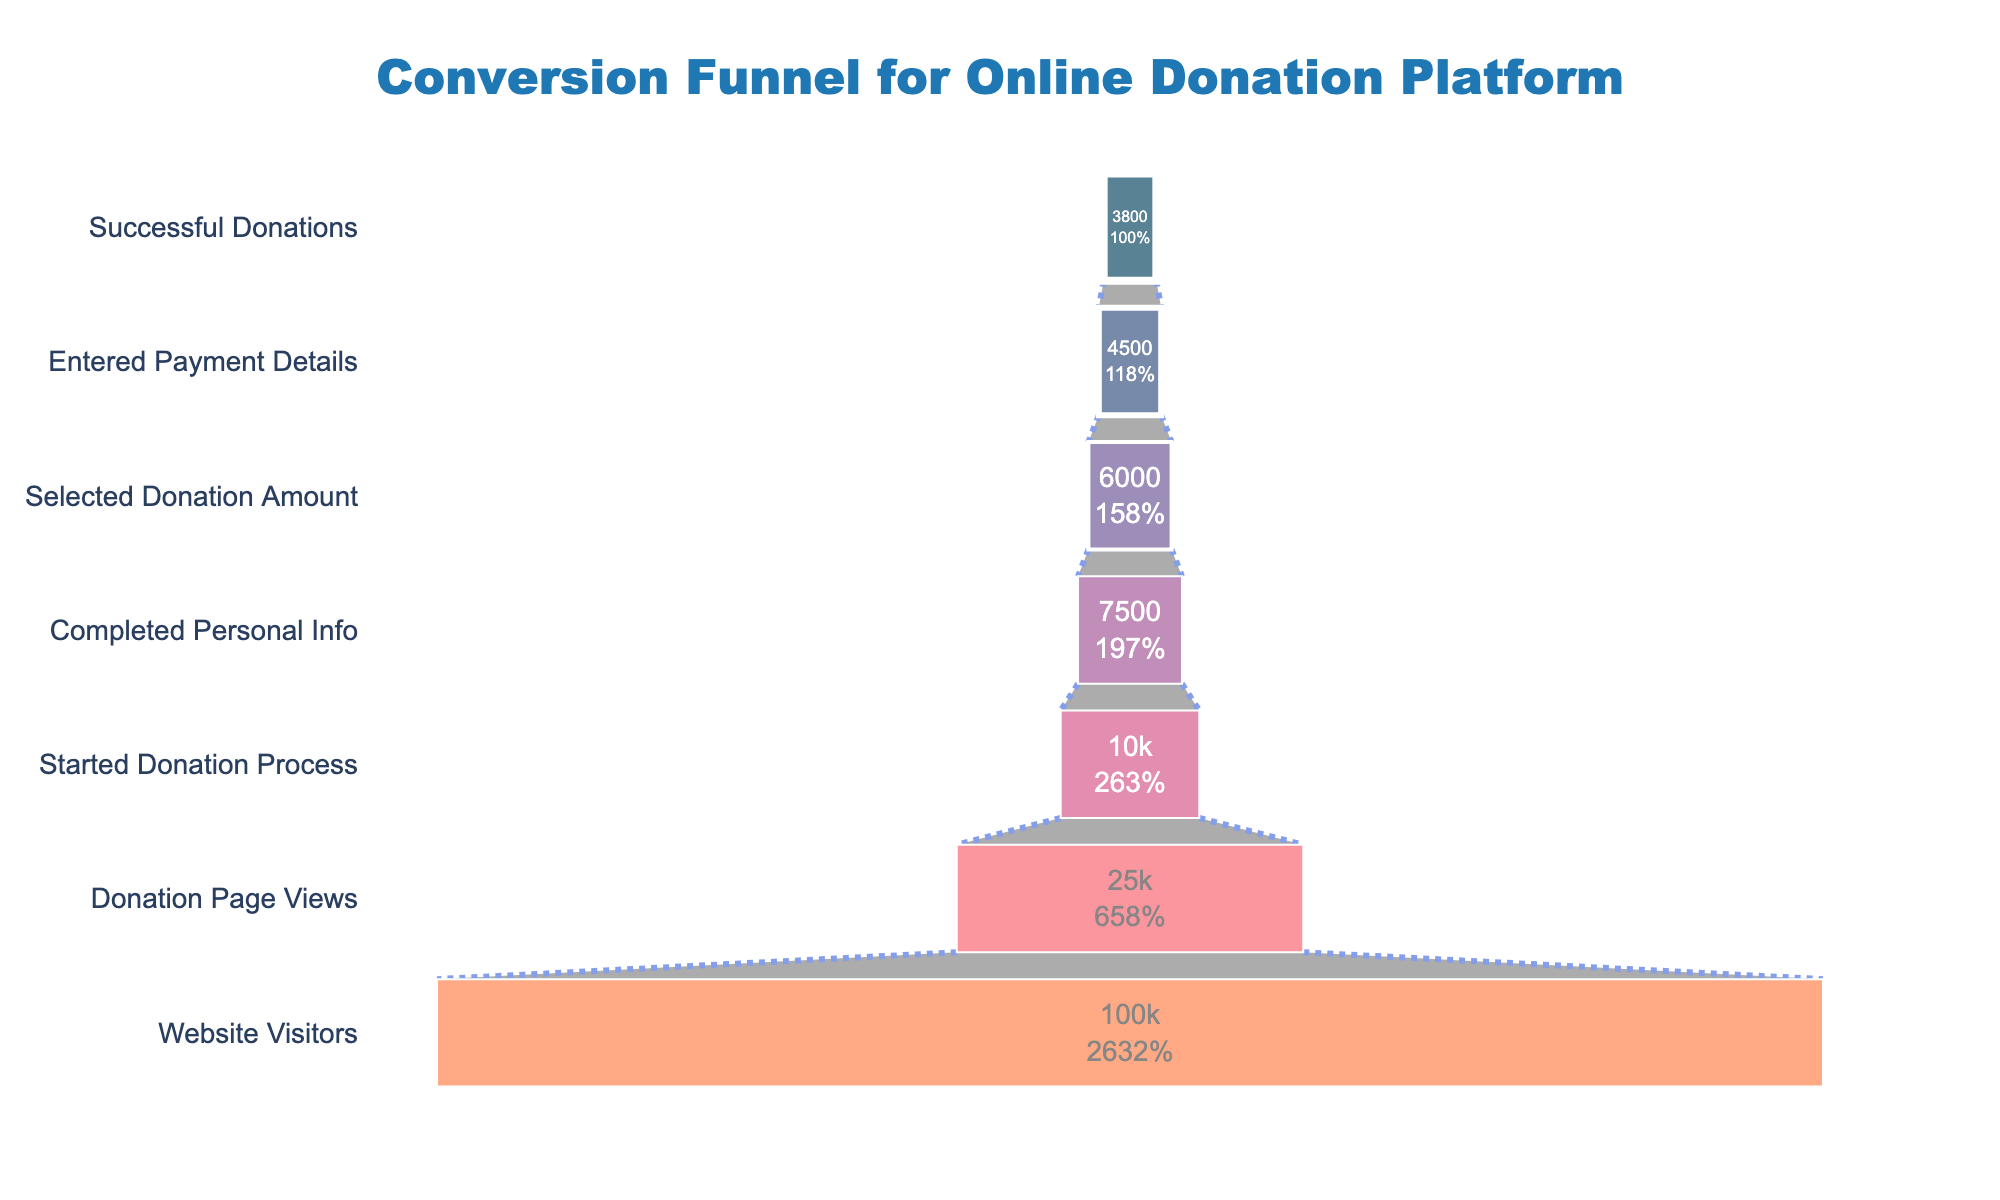How many stages are there in the conversion funnel? The figure shows different stages in the conversion funnel for an online donation platform. By counting the distinct stages listed vertically on the left side of the funnel, you can determine the number of stages.
Answer: 7 What is the title of the funnel chart? The title is usually placed at the top center of the chart. Looking at this position, you can identify the title used.
Answer: Conversion Funnel for Online Donation Platform What percentage of users who visited the website viewed the donation page? Take the number of users who viewed the donation page (25,000) and divide it by the number of website visitors (100,000), then multiply by 100 to get the percentage.
Answer: 25% How many users entered their payment details but failed to make a successful donation? Subtract the number of successful donations from the number of users who entered payment details. Entered payment details: 4,500. Successful donations: 3,800. The difference is the number of users who failed to make a donation.
Answer: 700 Which stage has the greatest drop-off in user count? By observing the decrease in the number of users between two consecutive stages, identify the stage with the largest reduction. Compare the drops: (100,000 - 25,000), (25,000 - 10,000), etc. The greatest drop-off occurs from website visitors to donation page views (75,000 users).
Answer: Website Visitors to Donation Page Views What is the ratio of users who started the donation process to those who completed their personal information? Divide the number of users who started the donation process (10,000) by those who completed their personal information (7,500). Simplify the ratio if possible.
Answer: 4:3 Which stage comes immediately before "Selected Donation Amount"? By looking at the ordered list of stages in the funnel chart, identify the stage listed just above the "Selected Donation Amount" stage.
Answer: Completed Personal Info What is the conversion rate from users who completed personal info to those who selected a donation amount? Use the numbers for users who completed personal information (7,500) and those who selected a donation amount (6,000). Divide 6,000 by 7,500 and multiply by 100 to get the percentage.
Answer: 80% Is there a consistent drop in the number of users at each stage, or are there stages with less user attrition? By examining the decrease in user numbers at each stage, check if the drop is uniform or if there are stages with smaller declines. For instance, compare the differences like (25,000 - 10,000) with (10,000 - 7,500).
Answer: There are stages with less attrition When observing the user count, which color represents the "Website Visitors" stage? Identify the funnel slice associated with "Website Visitors" and note the corresponding color. The "Website Visitors" stage is represented by the color at the topmost slice of the funnel.
Answer: #003f5c 